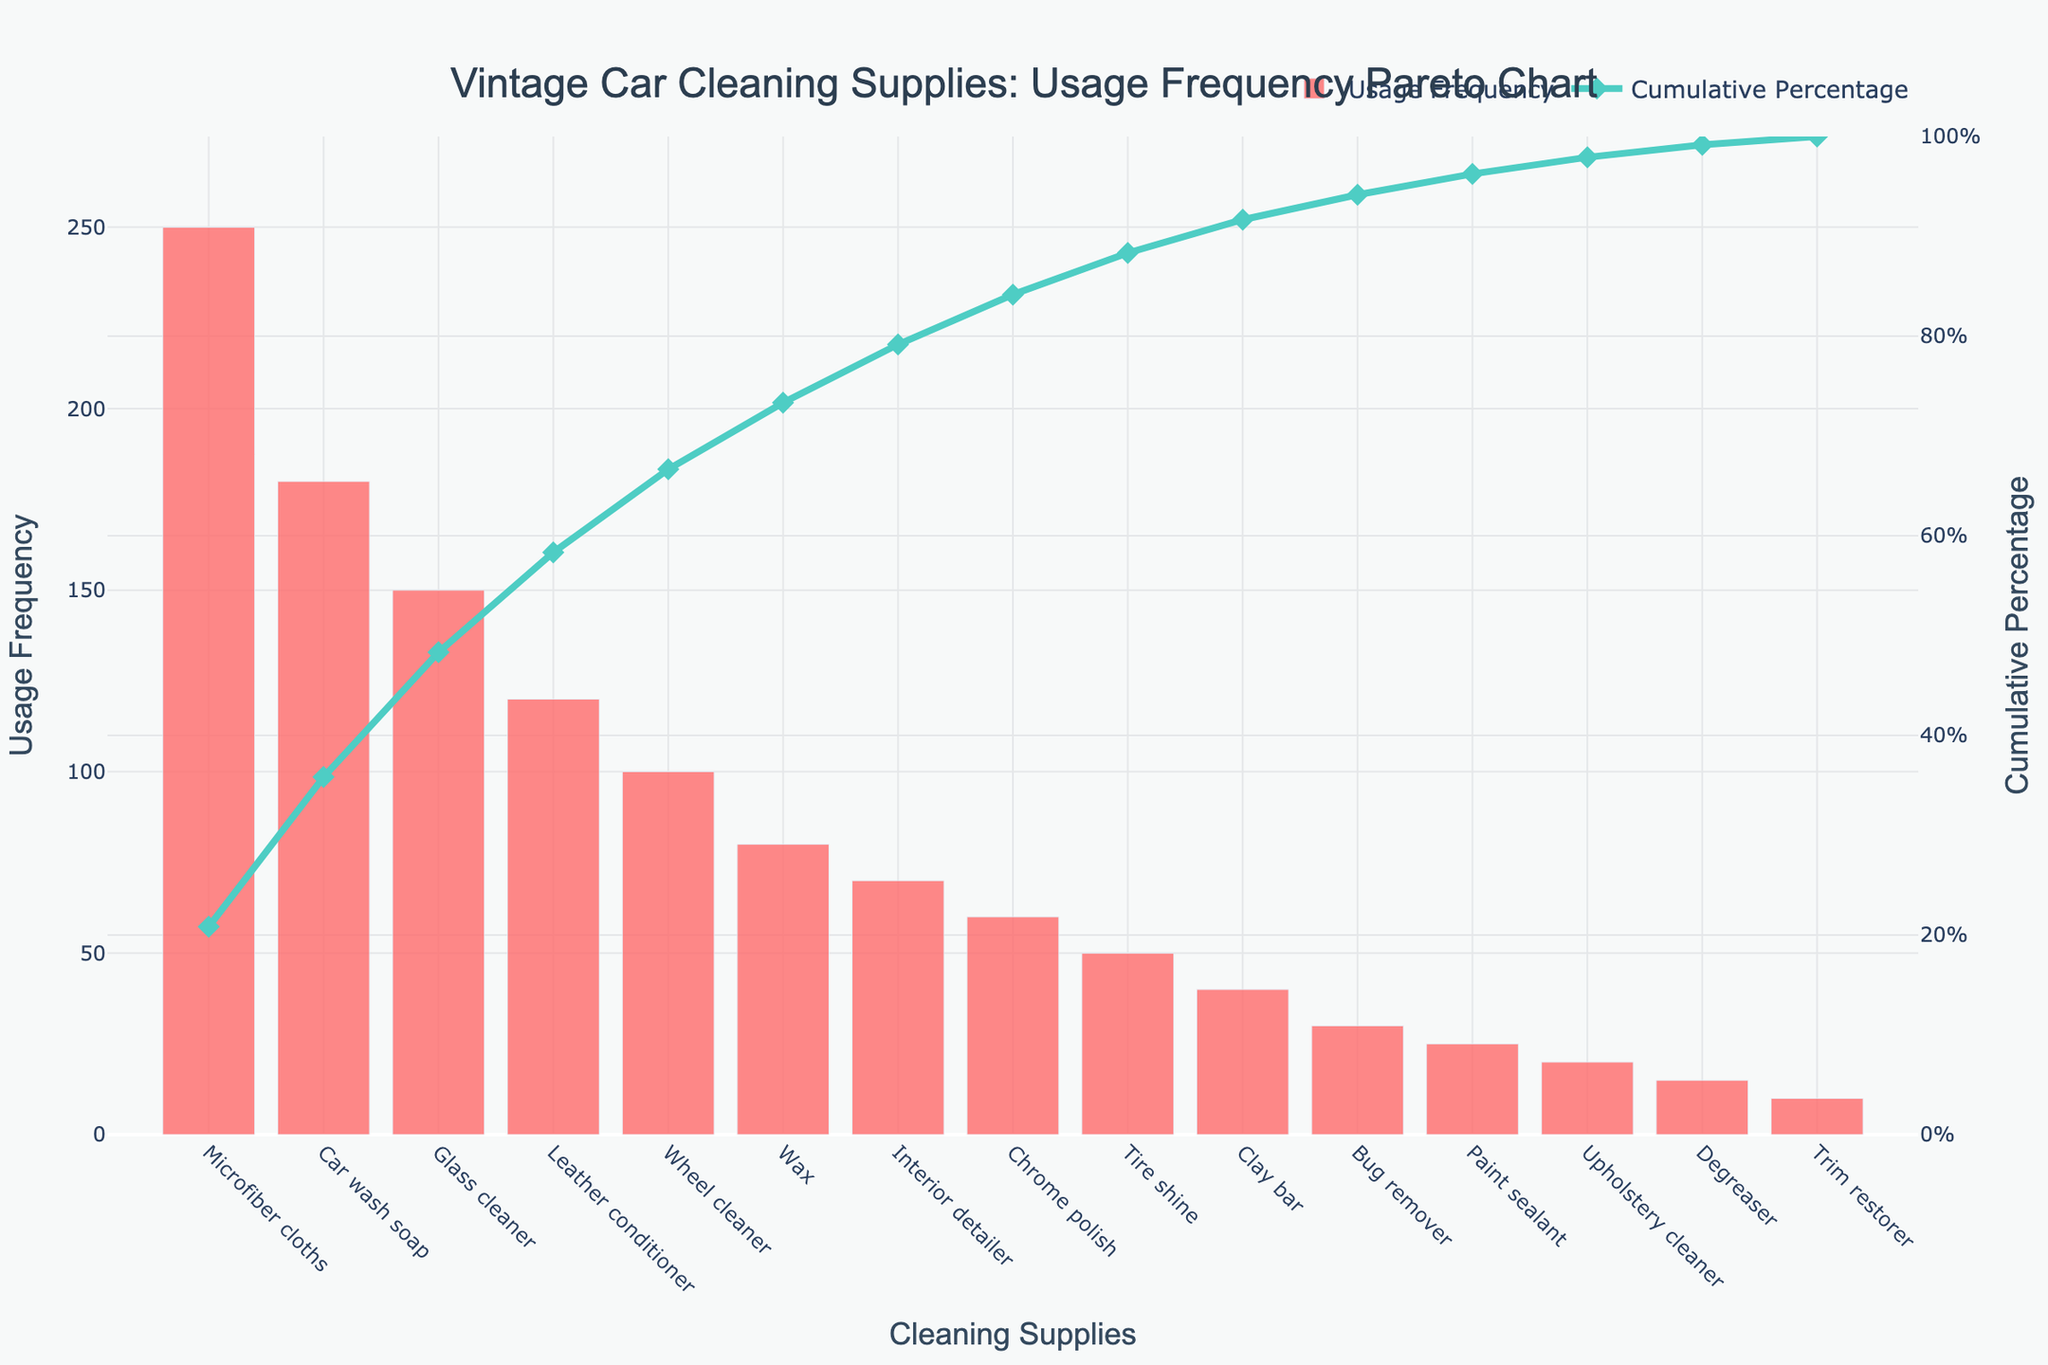Which cleaning supply is used the most? The cleaning supply with the highest bar represents the most frequently used cleaning supply. The bar for Microfiber cloths is the tallest.
Answer: Microfiber cloths What is the title of the Pareto chart? The title is usually located at the top of the chart and reads: "Vintage Car Cleaning Supplies: Usage Frequency Pareto Chart".
Answer: Vintage Car Cleaning Supplies: Usage Frequency Pareto Chart What is the cumulative percentage after adding Car wash soap? The cumulative percentage line's value directly above the bar for Car wash soap shows the cumulative usage percentage.
Answer: ~68.33% What's the combined usage frequency of the Wheel cleaner and Wax? Add the usage frequencies for Wheel cleaner (100) and Wax (80): 100 + 80 = 180
Answer: 180 Which cleaning supply is used more frequently: Leather conditioner or Chrome polish? Compare the heights of the bars for Leather conditioner and Chrome polish. Leather conditioner's bar is taller.
Answer: Leather conditioner What cleaning supply's usage gets the cumulative percentage to 80%? Look at where the cumulative percentage line reaches 80% on the secondary y-axis and find the corresponding cleaning supply on the x-axis.
Answer: Wheel cleaner After how many items does the cumulative percentage exceed 90%? Count the items from left until the cumulative percentage line surpasses 90%.
Answer: After 10 items What is the total usage frequency of the top three cleaning supplies? Sum the top three frequencies: Microfiber cloths (250), Car wash soap (180), and Glass cleaner (150): 250 + 180 + 150 = 580
Answer: 580 What's the difference in usage frequency between the least and the most used cleaning supply? Subtract the frequency of the least used (Trim restorer, 10) from the most used (Microfiber cloths, 250): 250 - 10 = 240
Answer: 240 What percentage of the total is accounted for by Microfiber cloths alone? The usage frequency of Microfiber cloths divided by the sum of all usage frequencies, multiplied by 100. The sum is 1300, so (250/1300) * 100 = ~19.23%
Answer: ~19.23% 